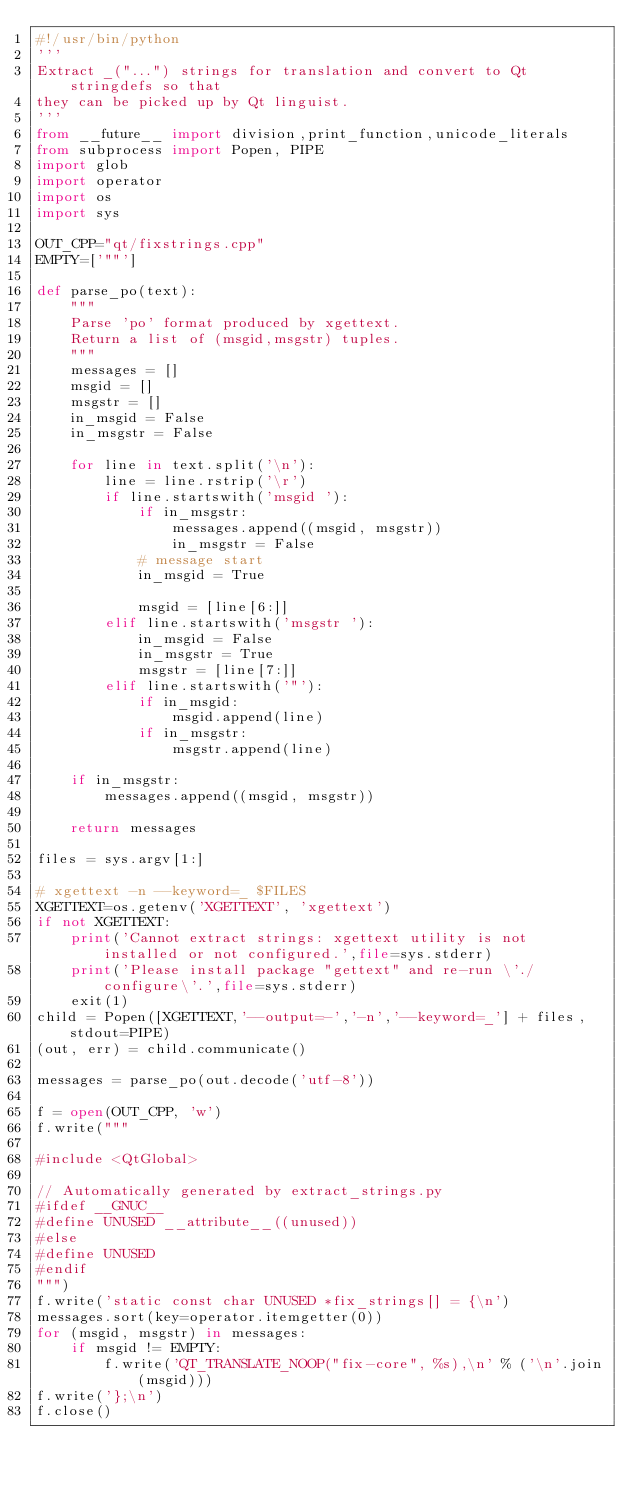<code> <loc_0><loc_0><loc_500><loc_500><_Python_>#!/usr/bin/python
'''
Extract _("...") strings for translation and convert to Qt stringdefs so that
they can be picked up by Qt linguist.
'''
from __future__ import division,print_function,unicode_literals
from subprocess import Popen, PIPE
import glob
import operator
import os
import sys

OUT_CPP="qt/fixstrings.cpp"
EMPTY=['""']

def parse_po(text):
    """
    Parse 'po' format produced by xgettext.
    Return a list of (msgid,msgstr) tuples.
    """
    messages = []
    msgid = []
    msgstr = []
    in_msgid = False
    in_msgstr = False

    for line in text.split('\n'):
        line = line.rstrip('\r')
        if line.startswith('msgid '):
            if in_msgstr:
                messages.append((msgid, msgstr))
                in_msgstr = False
            # message start
            in_msgid = True

            msgid = [line[6:]]
        elif line.startswith('msgstr '):
            in_msgid = False
            in_msgstr = True
            msgstr = [line[7:]]
        elif line.startswith('"'):
            if in_msgid:
                msgid.append(line)
            if in_msgstr:
                msgstr.append(line)

    if in_msgstr:
        messages.append((msgid, msgstr))

    return messages

files = sys.argv[1:]

# xgettext -n --keyword=_ $FILES
XGETTEXT=os.getenv('XGETTEXT', 'xgettext')
if not XGETTEXT:
    print('Cannot extract strings: xgettext utility is not installed or not configured.',file=sys.stderr)
    print('Please install package "gettext" and re-run \'./configure\'.',file=sys.stderr)
    exit(1)
child = Popen([XGETTEXT,'--output=-','-n','--keyword=_'] + files, stdout=PIPE)
(out, err) = child.communicate()

messages = parse_po(out.decode('utf-8'))

f = open(OUT_CPP, 'w')
f.write("""

#include <QtGlobal>

// Automatically generated by extract_strings.py
#ifdef __GNUC__
#define UNUSED __attribute__((unused))
#else
#define UNUSED
#endif
""")
f.write('static const char UNUSED *fix_strings[] = {\n')
messages.sort(key=operator.itemgetter(0))
for (msgid, msgstr) in messages:
    if msgid != EMPTY:
        f.write('QT_TRANSLATE_NOOP("fix-core", %s),\n' % ('\n'.join(msgid)))
f.write('};\n')
f.close()
</code> 